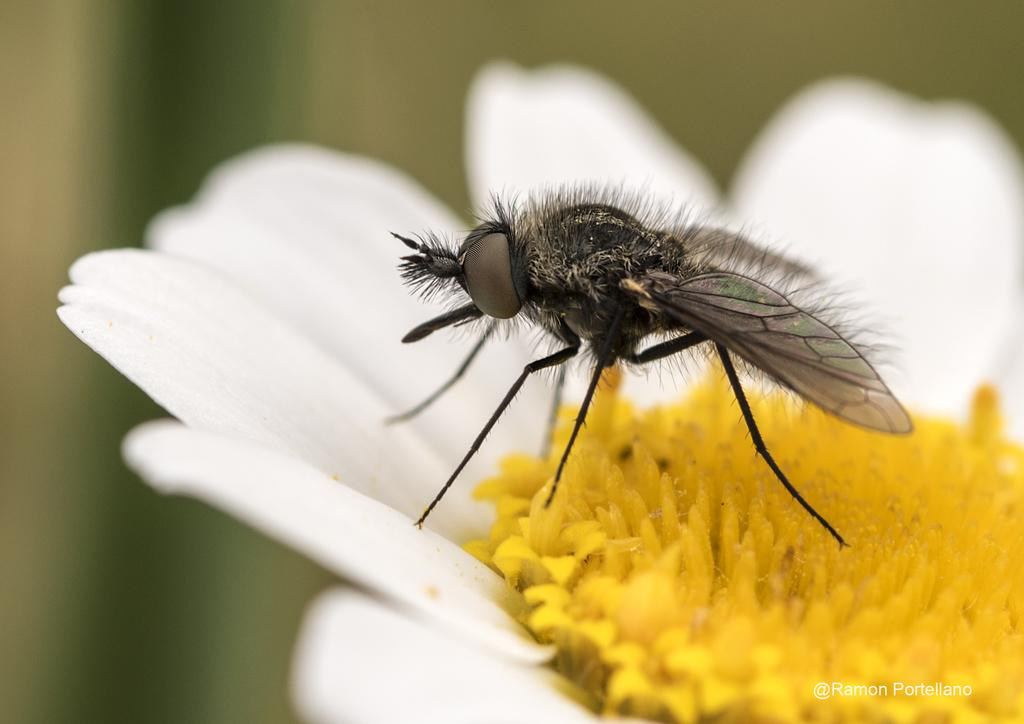What is present in the image along with the flower? There is an insect in the image. What is the insect doing in the image? The insect is standing on a flower. What is the color of the flower's center? The flower has a yellow color part in the middle. What can be seen in the bottom right corner of the image? There is a watermark in the bottom right corner of the image. How would you describe the background of the image? The background of the image is blurred. What type of bag is the insect carrying on its back in the image? There is no bag present on the insect in the image. How does the insect show fear in the image? The insect does not show fear in the image; it is standing on a flower. What scale is used to measure the size of the insect in the image? There is no scale present in the image to measure the size of the insect. 